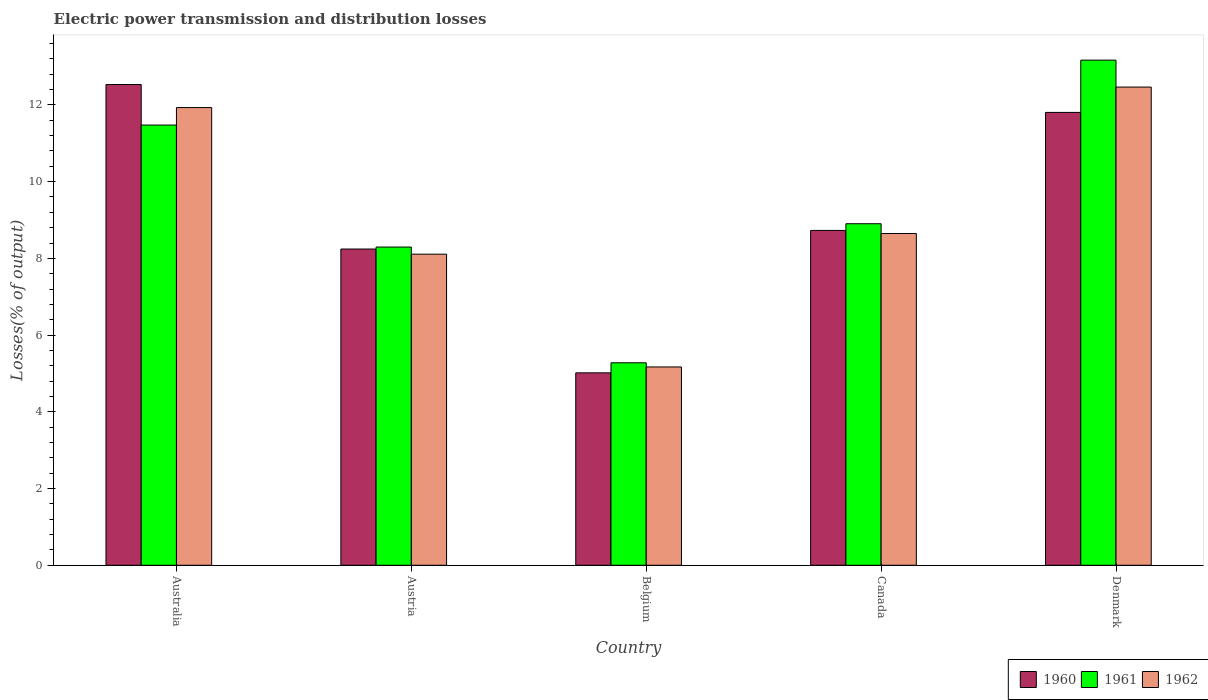Are the number of bars on each tick of the X-axis equal?
Provide a short and direct response. Yes. How many bars are there on the 5th tick from the left?
Ensure brevity in your answer.  3. How many bars are there on the 1st tick from the right?
Give a very brief answer. 3. In how many cases, is the number of bars for a given country not equal to the number of legend labels?
Provide a succinct answer. 0. What is the electric power transmission and distribution losses in 1962 in Australia?
Your answer should be compact. 11.93. Across all countries, what is the maximum electric power transmission and distribution losses in 1960?
Offer a terse response. 12.53. Across all countries, what is the minimum electric power transmission and distribution losses in 1960?
Your answer should be very brief. 5.02. What is the total electric power transmission and distribution losses in 1962 in the graph?
Offer a very short reply. 46.32. What is the difference between the electric power transmission and distribution losses in 1961 in Belgium and that in Denmark?
Your answer should be compact. -7.89. What is the difference between the electric power transmission and distribution losses in 1960 in Canada and the electric power transmission and distribution losses in 1961 in Australia?
Provide a succinct answer. -2.75. What is the average electric power transmission and distribution losses in 1962 per country?
Your answer should be very brief. 9.26. What is the difference between the electric power transmission and distribution losses of/in 1961 and electric power transmission and distribution losses of/in 1962 in Belgium?
Your response must be concise. 0.11. What is the ratio of the electric power transmission and distribution losses in 1961 in Australia to that in Denmark?
Your answer should be compact. 0.87. Is the electric power transmission and distribution losses in 1961 in Canada less than that in Denmark?
Your answer should be compact. Yes. Is the difference between the electric power transmission and distribution losses in 1961 in Austria and Canada greater than the difference between the electric power transmission and distribution losses in 1962 in Austria and Canada?
Your answer should be compact. No. What is the difference between the highest and the second highest electric power transmission and distribution losses in 1961?
Offer a terse response. -2.57. What is the difference between the highest and the lowest electric power transmission and distribution losses in 1962?
Your answer should be compact. 7.3. In how many countries, is the electric power transmission and distribution losses in 1961 greater than the average electric power transmission and distribution losses in 1961 taken over all countries?
Offer a terse response. 2. Is the sum of the electric power transmission and distribution losses in 1961 in Australia and Belgium greater than the maximum electric power transmission and distribution losses in 1960 across all countries?
Give a very brief answer. Yes. What does the 1st bar from the left in Canada represents?
Offer a very short reply. 1960. Is it the case that in every country, the sum of the electric power transmission and distribution losses in 1961 and electric power transmission and distribution losses in 1962 is greater than the electric power transmission and distribution losses in 1960?
Make the answer very short. Yes. How many bars are there?
Provide a short and direct response. 15. Are all the bars in the graph horizontal?
Make the answer very short. No. How many countries are there in the graph?
Your answer should be compact. 5. Are the values on the major ticks of Y-axis written in scientific E-notation?
Offer a terse response. No. Does the graph contain any zero values?
Make the answer very short. No. Where does the legend appear in the graph?
Keep it short and to the point. Bottom right. How many legend labels are there?
Your answer should be very brief. 3. What is the title of the graph?
Make the answer very short. Electric power transmission and distribution losses. What is the label or title of the Y-axis?
Ensure brevity in your answer.  Losses(% of output). What is the Losses(% of output) in 1960 in Australia?
Your response must be concise. 12.53. What is the Losses(% of output) of 1961 in Australia?
Ensure brevity in your answer.  11.48. What is the Losses(% of output) of 1962 in Australia?
Give a very brief answer. 11.93. What is the Losses(% of output) of 1960 in Austria?
Your response must be concise. 8.24. What is the Losses(% of output) in 1961 in Austria?
Provide a succinct answer. 8.3. What is the Losses(% of output) in 1962 in Austria?
Give a very brief answer. 8.11. What is the Losses(% of output) of 1960 in Belgium?
Provide a short and direct response. 5.02. What is the Losses(% of output) in 1961 in Belgium?
Offer a terse response. 5.28. What is the Losses(% of output) in 1962 in Belgium?
Make the answer very short. 5.17. What is the Losses(% of output) in 1960 in Canada?
Your response must be concise. 8.73. What is the Losses(% of output) in 1961 in Canada?
Make the answer very short. 8.9. What is the Losses(% of output) in 1962 in Canada?
Ensure brevity in your answer.  8.65. What is the Losses(% of output) in 1960 in Denmark?
Keep it short and to the point. 11.81. What is the Losses(% of output) of 1961 in Denmark?
Provide a succinct answer. 13.17. What is the Losses(% of output) in 1962 in Denmark?
Provide a short and direct response. 12.47. Across all countries, what is the maximum Losses(% of output) of 1960?
Keep it short and to the point. 12.53. Across all countries, what is the maximum Losses(% of output) of 1961?
Ensure brevity in your answer.  13.17. Across all countries, what is the maximum Losses(% of output) of 1962?
Your answer should be very brief. 12.47. Across all countries, what is the minimum Losses(% of output) in 1960?
Provide a short and direct response. 5.02. Across all countries, what is the minimum Losses(% of output) in 1961?
Offer a terse response. 5.28. Across all countries, what is the minimum Losses(% of output) of 1962?
Offer a terse response. 5.17. What is the total Losses(% of output) of 1960 in the graph?
Your answer should be compact. 46.33. What is the total Losses(% of output) in 1961 in the graph?
Offer a terse response. 47.12. What is the total Losses(% of output) of 1962 in the graph?
Your response must be concise. 46.32. What is the difference between the Losses(% of output) of 1960 in Australia and that in Austria?
Make the answer very short. 4.29. What is the difference between the Losses(% of output) in 1961 in Australia and that in Austria?
Offer a very short reply. 3.18. What is the difference between the Losses(% of output) of 1962 in Australia and that in Austria?
Ensure brevity in your answer.  3.82. What is the difference between the Losses(% of output) of 1960 in Australia and that in Belgium?
Make the answer very short. 7.52. What is the difference between the Losses(% of output) of 1961 in Australia and that in Belgium?
Keep it short and to the point. 6.2. What is the difference between the Losses(% of output) in 1962 in Australia and that in Belgium?
Your answer should be very brief. 6.76. What is the difference between the Losses(% of output) of 1960 in Australia and that in Canada?
Your response must be concise. 3.8. What is the difference between the Losses(% of output) in 1961 in Australia and that in Canada?
Provide a short and direct response. 2.57. What is the difference between the Losses(% of output) of 1962 in Australia and that in Canada?
Your answer should be very brief. 3.28. What is the difference between the Losses(% of output) of 1960 in Australia and that in Denmark?
Give a very brief answer. 0.73. What is the difference between the Losses(% of output) of 1961 in Australia and that in Denmark?
Offer a terse response. -1.69. What is the difference between the Losses(% of output) of 1962 in Australia and that in Denmark?
Make the answer very short. -0.53. What is the difference between the Losses(% of output) in 1960 in Austria and that in Belgium?
Ensure brevity in your answer.  3.23. What is the difference between the Losses(% of output) of 1961 in Austria and that in Belgium?
Your response must be concise. 3.02. What is the difference between the Losses(% of output) of 1962 in Austria and that in Belgium?
Ensure brevity in your answer.  2.94. What is the difference between the Losses(% of output) of 1960 in Austria and that in Canada?
Your answer should be compact. -0.48. What is the difference between the Losses(% of output) of 1961 in Austria and that in Canada?
Offer a terse response. -0.61. What is the difference between the Losses(% of output) in 1962 in Austria and that in Canada?
Provide a succinct answer. -0.54. What is the difference between the Losses(% of output) of 1960 in Austria and that in Denmark?
Ensure brevity in your answer.  -3.56. What is the difference between the Losses(% of output) in 1961 in Austria and that in Denmark?
Provide a short and direct response. -4.87. What is the difference between the Losses(% of output) in 1962 in Austria and that in Denmark?
Keep it short and to the point. -4.36. What is the difference between the Losses(% of output) in 1960 in Belgium and that in Canada?
Your response must be concise. -3.71. What is the difference between the Losses(% of output) in 1961 in Belgium and that in Canada?
Make the answer very short. -3.63. What is the difference between the Losses(% of output) of 1962 in Belgium and that in Canada?
Keep it short and to the point. -3.48. What is the difference between the Losses(% of output) in 1960 in Belgium and that in Denmark?
Offer a terse response. -6.79. What is the difference between the Losses(% of output) in 1961 in Belgium and that in Denmark?
Provide a short and direct response. -7.89. What is the difference between the Losses(% of output) of 1962 in Belgium and that in Denmark?
Your response must be concise. -7.3. What is the difference between the Losses(% of output) in 1960 in Canada and that in Denmark?
Give a very brief answer. -3.08. What is the difference between the Losses(% of output) of 1961 in Canada and that in Denmark?
Provide a short and direct response. -4.26. What is the difference between the Losses(% of output) of 1962 in Canada and that in Denmark?
Give a very brief answer. -3.82. What is the difference between the Losses(% of output) in 1960 in Australia and the Losses(% of output) in 1961 in Austria?
Offer a very short reply. 4.24. What is the difference between the Losses(% of output) of 1960 in Australia and the Losses(% of output) of 1962 in Austria?
Give a very brief answer. 4.42. What is the difference between the Losses(% of output) of 1961 in Australia and the Losses(% of output) of 1962 in Austria?
Your answer should be compact. 3.37. What is the difference between the Losses(% of output) of 1960 in Australia and the Losses(% of output) of 1961 in Belgium?
Keep it short and to the point. 7.25. What is the difference between the Losses(% of output) in 1960 in Australia and the Losses(% of output) in 1962 in Belgium?
Ensure brevity in your answer.  7.36. What is the difference between the Losses(% of output) in 1961 in Australia and the Losses(% of output) in 1962 in Belgium?
Your answer should be very brief. 6.31. What is the difference between the Losses(% of output) in 1960 in Australia and the Losses(% of output) in 1961 in Canada?
Offer a very short reply. 3.63. What is the difference between the Losses(% of output) of 1960 in Australia and the Losses(% of output) of 1962 in Canada?
Provide a succinct answer. 3.88. What is the difference between the Losses(% of output) in 1961 in Australia and the Losses(% of output) in 1962 in Canada?
Keep it short and to the point. 2.83. What is the difference between the Losses(% of output) in 1960 in Australia and the Losses(% of output) in 1961 in Denmark?
Offer a terse response. -0.64. What is the difference between the Losses(% of output) of 1960 in Australia and the Losses(% of output) of 1962 in Denmark?
Ensure brevity in your answer.  0.07. What is the difference between the Losses(% of output) in 1961 in Australia and the Losses(% of output) in 1962 in Denmark?
Keep it short and to the point. -0.99. What is the difference between the Losses(% of output) of 1960 in Austria and the Losses(% of output) of 1961 in Belgium?
Keep it short and to the point. 2.97. What is the difference between the Losses(% of output) in 1960 in Austria and the Losses(% of output) in 1962 in Belgium?
Your response must be concise. 3.07. What is the difference between the Losses(% of output) of 1961 in Austria and the Losses(% of output) of 1962 in Belgium?
Give a very brief answer. 3.13. What is the difference between the Losses(% of output) of 1960 in Austria and the Losses(% of output) of 1961 in Canada?
Offer a terse response. -0.66. What is the difference between the Losses(% of output) of 1960 in Austria and the Losses(% of output) of 1962 in Canada?
Ensure brevity in your answer.  -0.4. What is the difference between the Losses(% of output) in 1961 in Austria and the Losses(% of output) in 1962 in Canada?
Provide a short and direct response. -0.35. What is the difference between the Losses(% of output) in 1960 in Austria and the Losses(% of output) in 1961 in Denmark?
Your answer should be compact. -4.92. What is the difference between the Losses(% of output) in 1960 in Austria and the Losses(% of output) in 1962 in Denmark?
Provide a short and direct response. -4.22. What is the difference between the Losses(% of output) of 1961 in Austria and the Losses(% of output) of 1962 in Denmark?
Your answer should be very brief. -4.17. What is the difference between the Losses(% of output) in 1960 in Belgium and the Losses(% of output) in 1961 in Canada?
Your response must be concise. -3.89. What is the difference between the Losses(% of output) of 1960 in Belgium and the Losses(% of output) of 1962 in Canada?
Your response must be concise. -3.63. What is the difference between the Losses(% of output) of 1961 in Belgium and the Losses(% of output) of 1962 in Canada?
Provide a short and direct response. -3.37. What is the difference between the Losses(% of output) in 1960 in Belgium and the Losses(% of output) in 1961 in Denmark?
Offer a very short reply. -8.15. What is the difference between the Losses(% of output) in 1960 in Belgium and the Losses(% of output) in 1962 in Denmark?
Your answer should be compact. -7.45. What is the difference between the Losses(% of output) of 1961 in Belgium and the Losses(% of output) of 1962 in Denmark?
Your response must be concise. -7.19. What is the difference between the Losses(% of output) in 1960 in Canada and the Losses(% of output) in 1961 in Denmark?
Ensure brevity in your answer.  -4.44. What is the difference between the Losses(% of output) in 1960 in Canada and the Losses(% of output) in 1962 in Denmark?
Your answer should be compact. -3.74. What is the difference between the Losses(% of output) in 1961 in Canada and the Losses(% of output) in 1962 in Denmark?
Make the answer very short. -3.56. What is the average Losses(% of output) of 1960 per country?
Provide a succinct answer. 9.27. What is the average Losses(% of output) of 1961 per country?
Your answer should be compact. 9.42. What is the average Losses(% of output) in 1962 per country?
Offer a terse response. 9.26. What is the difference between the Losses(% of output) of 1960 and Losses(% of output) of 1961 in Australia?
Provide a short and direct response. 1.06. What is the difference between the Losses(% of output) in 1960 and Losses(% of output) in 1962 in Australia?
Keep it short and to the point. 0.6. What is the difference between the Losses(% of output) of 1961 and Losses(% of output) of 1962 in Australia?
Provide a succinct answer. -0.46. What is the difference between the Losses(% of output) of 1960 and Losses(% of output) of 1961 in Austria?
Offer a terse response. -0.05. What is the difference between the Losses(% of output) of 1960 and Losses(% of output) of 1962 in Austria?
Keep it short and to the point. 0.13. What is the difference between the Losses(% of output) of 1961 and Losses(% of output) of 1962 in Austria?
Offer a terse response. 0.19. What is the difference between the Losses(% of output) in 1960 and Losses(% of output) in 1961 in Belgium?
Make the answer very short. -0.26. What is the difference between the Losses(% of output) in 1960 and Losses(% of output) in 1962 in Belgium?
Offer a very short reply. -0.15. What is the difference between the Losses(% of output) in 1961 and Losses(% of output) in 1962 in Belgium?
Offer a terse response. 0.11. What is the difference between the Losses(% of output) of 1960 and Losses(% of output) of 1961 in Canada?
Make the answer very short. -0.17. What is the difference between the Losses(% of output) of 1961 and Losses(% of output) of 1962 in Canada?
Offer a very short reply. 0.25. What is the difference between the Losses(% of output) of 1960 and Losses(% of output) of 1961 in Denmark?
Offer a terse response. -1.36. What is the difference between the Losses(% of output) in 1960 and Losses(% of output) in 1962 in Denmark?
Make the answer very short. -0.66. What is the difference between the Losses(% of output) of 1961 and Losses(% of output) of 1962 in Denmark?
Your answer should be compact. 0.7. What is the ratio of the Losses(% of output) in 1960 in Australia to that in Austria?
Keep it short and to the point. 1.52. What is the ratio of the Losses(% of output) of 1961 in Australia to that in Austria?
Your answer should be very brief. 1.38. What is the ratio of the Losses(% of output) of 1962 in Australia to that in Austria?
Offer a terse response. 1.47. What is the ratio of the Losses(% of output) in 1960 in Australia to that in Belgium?
Offer a terse response. 2.5. What is the ratio of the Losses(% of output) in 1961 in Australia to that in Belgium?
Your answer should be compact. 2.17. What is the ratio of the Losses(% of output) of 1962 in Australia to that in Belgium?
Make the answer very short. 2.31. What is the ratio of the Losses(% of output) of 1960 in Australia to that in Canada?
Offer a terse response. 1.44. What is the ratio of the Losses(% of output) of 1961 in Australia to that in Canada?
Provide a short and direct response. 1.29. What is the ratio of the Losses(% of output) of 1962 in Australia to that in Canada?
Your response must be concise. 1.38. What is the ratio of the Losses(% of output) of 1960 in Australia to that in Denmark?
Your response must be concise. 1.06. What is the ratio of the Losses(% of output) of 1961 in Australia to that in Denmark?
Make the answer very short. 0.87. What is the ratio of the Losses(% of output) in 1962 in Australia to that in Denmark?
Provide a succinct answer. 0.96. What is the ratio of the Losses(% of output) of 1960 in Austria to that in Belgium?
Your answer should be very brief. 1.64. What is the ratio of the Losses(% of output) of 1961 in Austria to that in Belgium?
Your response must be concise. 1.57. What is the ratio of the Losses(% of output) in 1962 in Austria to that in Belgium?
Your response must be concise. 1.57. What is the ratio of the Losses(% of output) in 1960 in Austria to that in Canada?
Provide a short and direct response. 0.94. What is the ratio of the Losses(% of output) in 1961 in Austria to that in Canada?
Provide a short and direct response. 0.93. What is the ratio of the Losses(% of output) of 1962 in Austria to that in Canada?
Provide a short and direct response. 0.94. What is the ratio of the Losses(% of output) of 1960 in Austria to that in Denmark?
Make the answer very short. 0.7. What is the ratio of the Losses(% of output) in 1961 in Austria to that in Denmark?
Your answer should be compact. 0.63. What is the ratio of the Losses(% of output) in 1962 in Austria to that in Denmark?
Ensure brevity in your answer.  0.65. What is the ratio of the Losses(% of output) of 1960 in Belgium to that in Canada?
Offer a terse response. 0.57. What is the ratio of the Losses(% of output) of 1961 in Belgium to that in Canada?
Provide a short and direct response. 0.59. What is the ratio of the Losses(% of output) in 1962 in Belgium to that in Canada?
Offer a terse response. 0.6. What is the ratio of the Losses(% of output) in 1960 in Belgium to that in Denmark?
Keep it short and to the point. 0.42. What is the ratio of the Losses(% of output) of 1961 in Belgium to that in Denmark?
Your answer should be very brief. 0.4. What is the ratio of the Losses(% of output) of 1962 in Belgium to that in Denmark?
Give a very brief answer. 0.41. What is the ratio of the Losses(% of output) of 1960 in Canada to that in Denmark?
Make the answer very short. 0.74. What is the ratio of the Losses(% of output) in 1961 in Canada to that in Denmark?
Make the answer very short. 0.68. What is the ratio of the Losses(% of output) in 1962 in Canada to that in Denmark?
Keep it short and to the point. 0.69. What is the difference between the highest and the second highest Losses(% of output) in 1960?
Your response must be concise. 0.73. What is the difference between the highest and the second highest Losses(% of output) in 1961?
Ensure brevity in your answer.  1.69. What is the difference between the highest and the second highest Losses(% of output) in 1962?
Your answer should be very brief. 0.53. What is the difference between the highest and the lowest Losses(% of output) of 1960?
Provide a succinct answer. 7.52. What is the difference between the highest and the lowest Losses(% of output) of 1961?
Your response must be concise. 7.89. What is the difference between the highest and the lowest Losses(% of output) of 1962?
Provide a succinct answer. 7.3. 